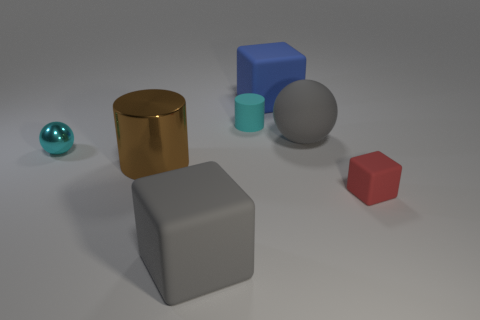Subtract all large blocks. How many blocks are left? 1 Subtract 1 blocks. How many blocks are left? 2 Add 2 small brown shiny cylinders. How many objects exist? 9 Subtract all cylinders. How many objects are left? 5 Subtract all cyan blocks. Subtract all purple cylinders. How many blocks are left? 3 Subtract 1 cyan cylinders. How many objects are left? 6 Subtract all tiny green metallic objects. Subtract all tiny matte blocks. How many objects are left? 6 Add 6 red matte objects. How many red matte objects are left? 7 Add 4 small brown rubber cylinders. How many small brown rubber cylinders exist? 4 